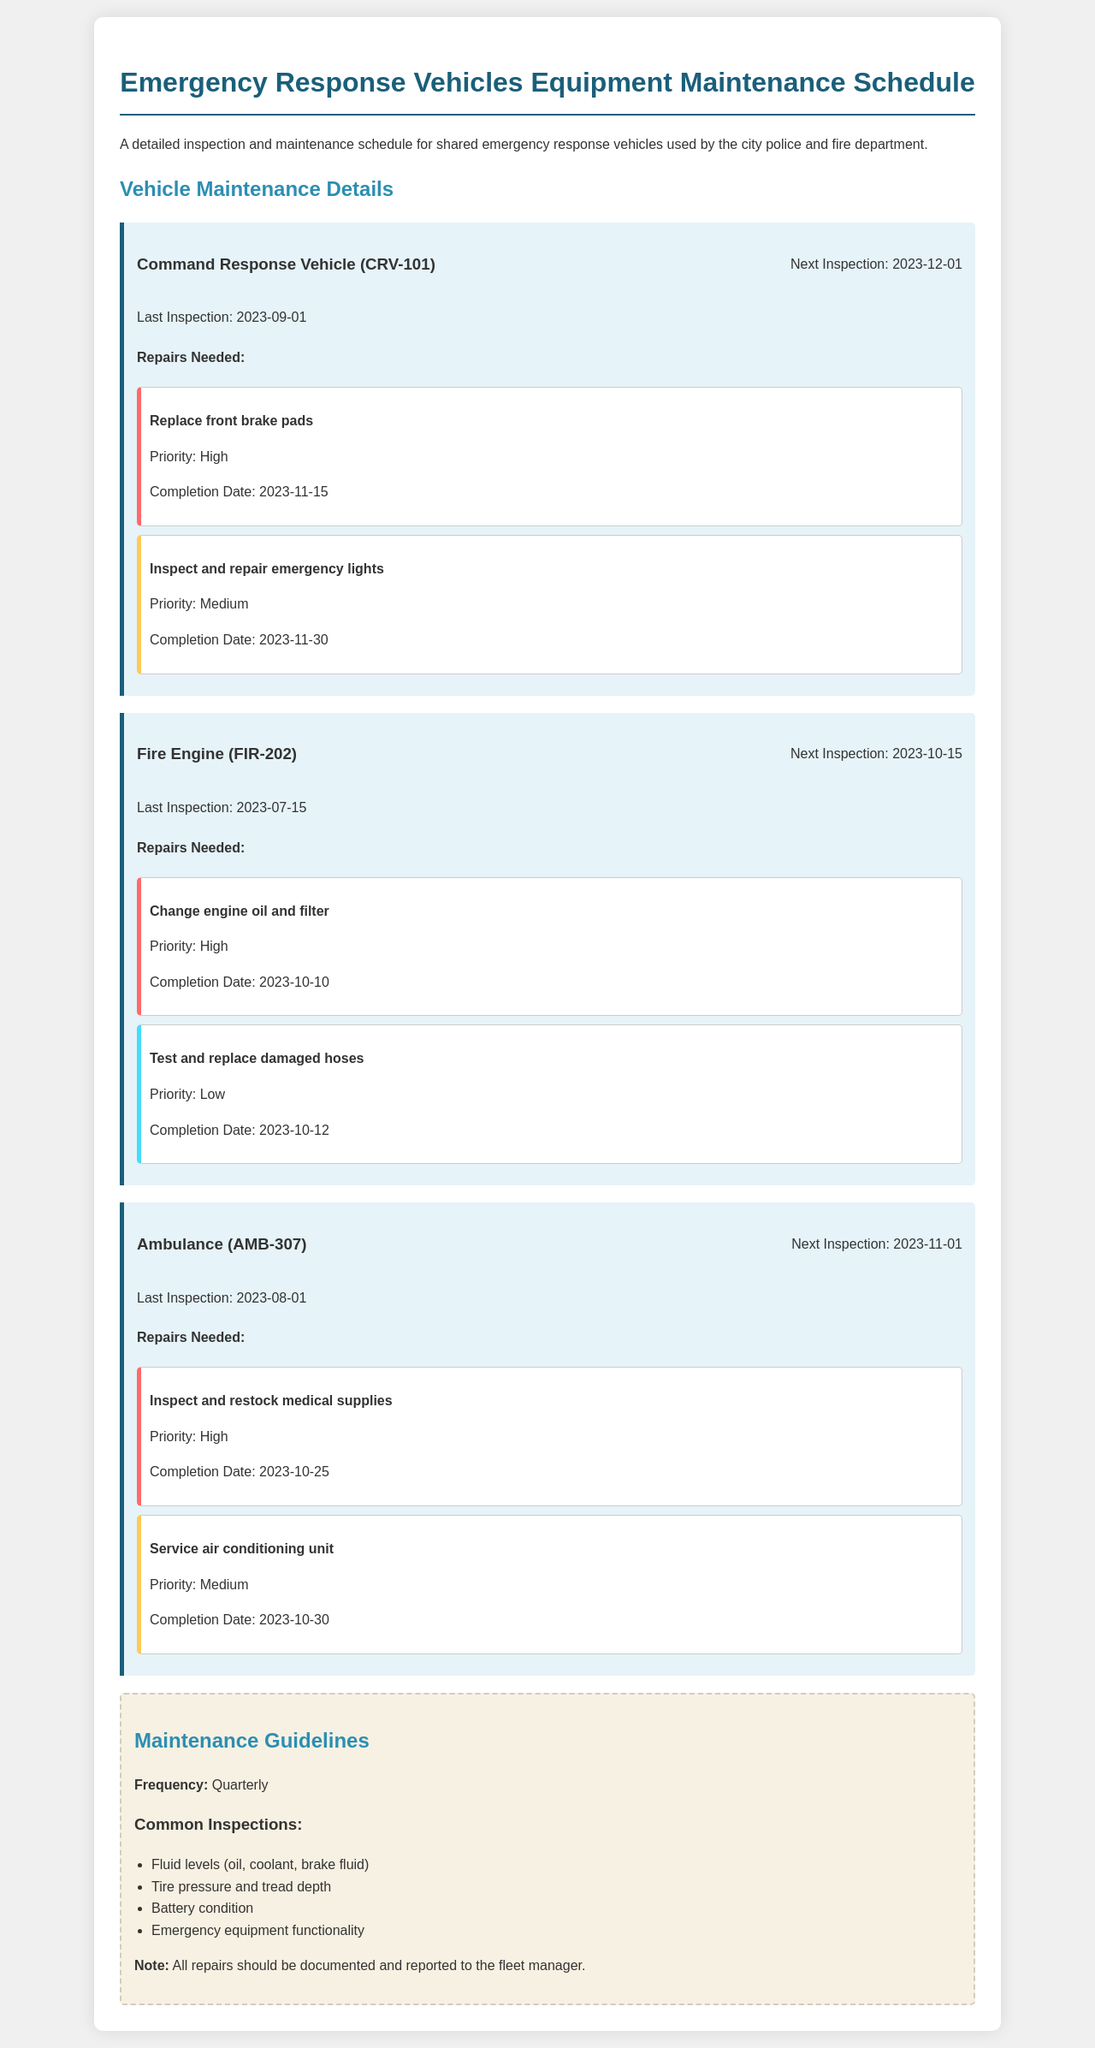What is the next inspection date for CRV-101? The next inspection date for CRV-101 is specified in the document as 2023-12-01.
Answer: 2023-12-01 What repairs are needed for the Fire Engine? The document lists repairs needed for the Fire Engine, including changing the engine oil and filter and testing and replacing damaged hoses.
Answer: Change engine oil and filter, Test and replace damaged hoses What is the priority of the repair to service the air conditioning unit in the Ambulance? The priority of the repair to service the air conditioning unit in the Ambulance is detailed in the document as Medium.
Answer: Medium When was the last inspection for the Fire Engine? The last inspection date for the Fire Engine can be found in the document and is listed as 2023-07-15.
Answer: 2023-07-15 What is the completion date for replacing the front brake pads on the Command Response Vehicle? The completion date for replacing the front brake pads on the Command Response Vehicle is noted in the document as 2023-11-15.
Answer: 2023-11-15 How often are the vehicles inspected according to the maintenance guidelines? The maintenance guidelines state the frequency of inspections, which is set as quarterly.
Answer: Quarterly What is the name of the vehicle with the highest priority repair? The name of the vehicle with the highest priority repair can be found in the document; it is the Command Response Vehicle.
Answer: Command Response Vehicle Which vehicle requires the inspection and restocking of medical supplies? The document specifies that the Ambulance requires the inspection and restocking of medical supplies as a repair.
Answer: Ambulance What is the priority of testing damaged hoses for the Fire Engine? The document indicates that the priority of testing damaged hoses for the Fire Engine is Low.
Answer: Low 